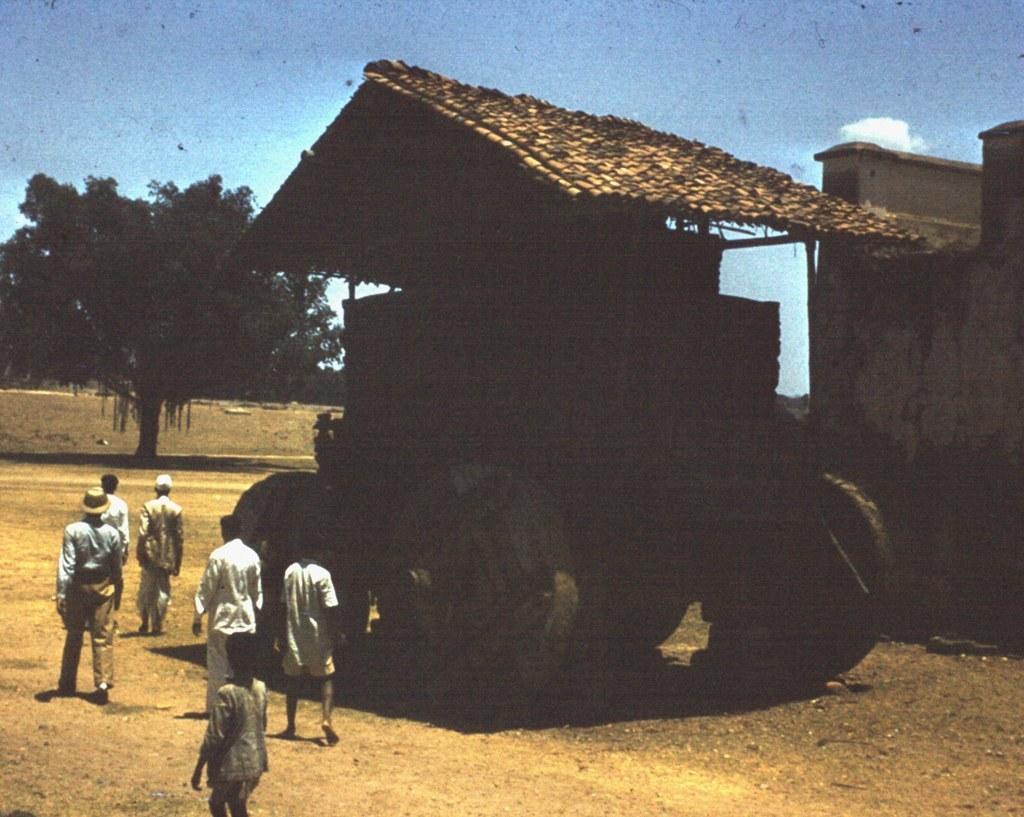Please provide a concise description of this image. In the center of the image we can see one vehicle, which looks like wooden house. And we can see a few people are walking and they are in different costumes. In the background, we can see the sky, clouds, one building, one tree, compound wall and a few other objects. 